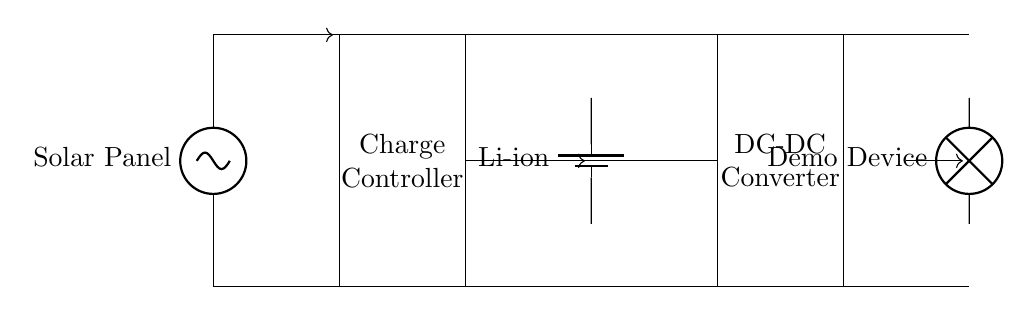What component converts solar energy into electrical energy? The circuit begins with a solar panel that is clearly labeled. This component captures sunlight and converts it into direct current electricity.
Answer: Solar Panel What type of battery is used in the circuit? The circuit diagram indicates a lithium-ion battery through the label next to the battery symbol. This type of battery is commonly used in portable devices for its energy density and rechargeability.
Answer: Li-ion What is the function of the charge controller? The charge controller is labeled in the circuit and is designed to manage the power flow from the solar panel to the battery, preventing overcharging and ensuring efficient charging.
Answer: Manage power flow How does power flow from the solar panel to the demo device? The circuit shows a clear path with arrows indicating current direction, starting from the solar panel, going through the charge controller, to the battery, then to the DC-DC converter, and finally to the demo device. This sequence illustrates the flow of energy from generation to consumption.
Answer: Through multiple components What is the purpose of the DC-DC converter? The DC-DC converter is labeled and is used to adjust the voltage level required by the demo device. It takes the voltage from the battery and converts it to the appropriate level needed for operation, ensuring efficiency in power usage.
Answer: Adjust voltage How many main components are involved in this solar charging circuit? By counting the distinct parts in the diagram—solar panel, charge controller, battery, DC-DC converter, and demo device—we can identify a total of five main components in the circuit.
Answer: Five 